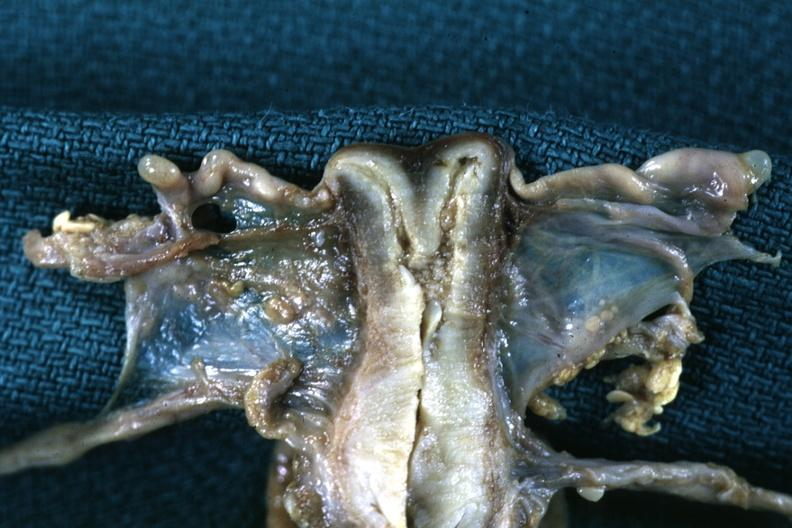s female reproductive present?
Answer the question using a single word or phrase. Yes 